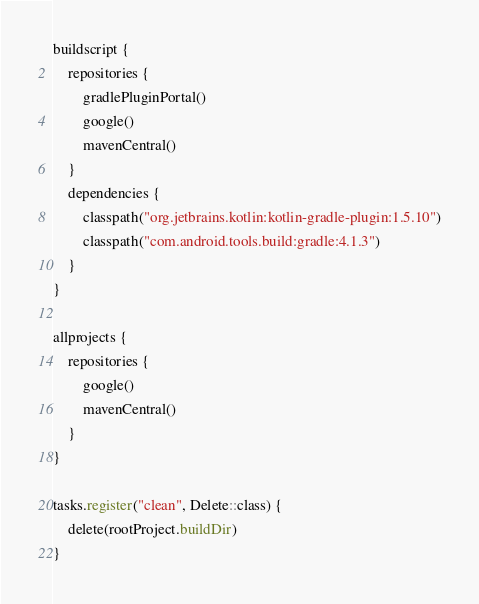<code> <loc_0><loc_0><loc_500><loc_500><_Kotlin_>buildscript {
    repositories {
        gradlePluginPortal()
        google()
        mavenCentral()
    }
    dependencies {
        classpath("org.jetbrains.kotlin:kotlin-gradle-plugin:1.5.10")
        classpath("com.android.tools.build:gradle:4.1.3")
    }
}

allprojects {
    repositories {
        google()
        mavenCentral()
    }
}

tasks.register("clean", Delete::class) {
    delete(rootProject.buildDir)
}</code> 